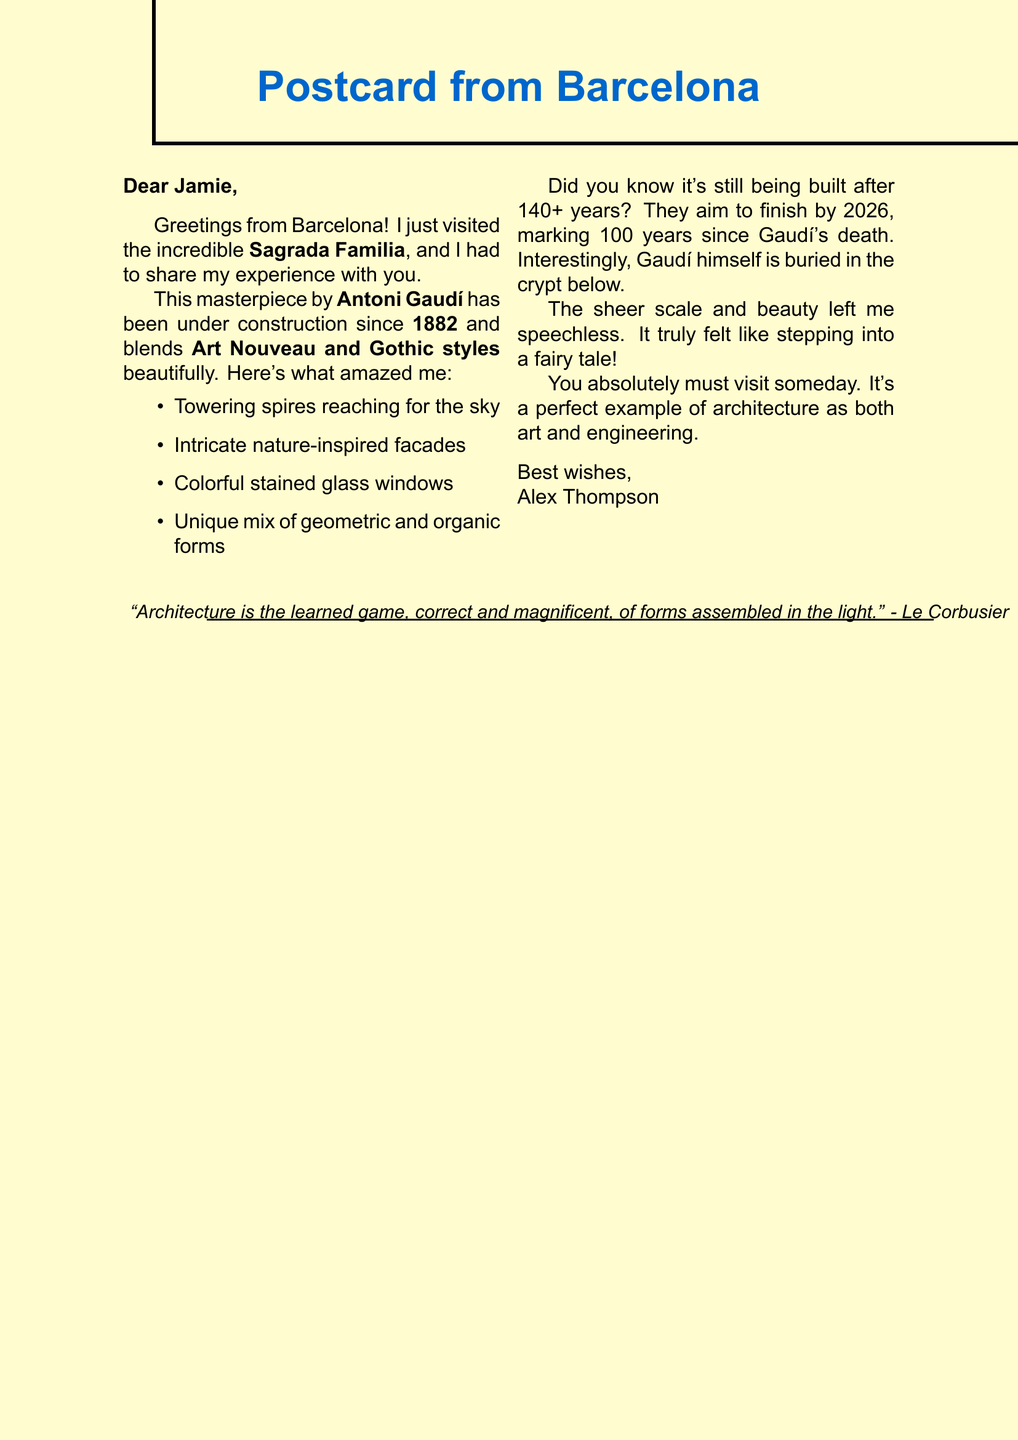What is the name of the architect of Sagrada Familia? The architect of Sagrada Familia is mentioned in the document as Antoni Gaudí.
Answer: Antoni Gaudí What city is the Sagrada Familia located in? The postcard mentions that the Sagrada Familia is located in Barcelona, Spain.
Answer: Barcelona What year did the construction of Sagrada Familia begin? The document states that construction began in 1882.
Answer: 1882 How long has the Sagrada Familia been under construction as of now? According to the document, it has been under construction for over 140 years.
Answer: 140 years What architectural styles are blended in the Sagrada Familia? The document describes the architectural styles as Art Nouveau and Gothic.
Answer: Art Nouveau and Gothic What is one of the key observations made by Alex about the Sagrada Familia? The document lists several key observations made by Alex about the building's features. One is the towering spires that seem to touch the sky.
Answer: Towering spires What is the expected completion year of Sagrada Familia? The document provides information on the expected completion, which is by 2026.
Answer: 2026 In which part of the Sagrada Familia is Antoni Gaudí buried? The postcard mentions that Gaudí is buried in the crypt beneath the church.
Answer: Crypt beneath the church What was Alex's personal feeling about the experience at Sagrada Familia? Alex expressed a sense of amazement at the scale and beauty of the building, describing it as stepping into a fairy tale.
Answer: Stepping into a fairy tale What does Alex recommend about visiting Sagrada Familia? The document includes a strong recommendation from Alex that one must visit Sagrada Familia someday.
Answer: Must visit someday 